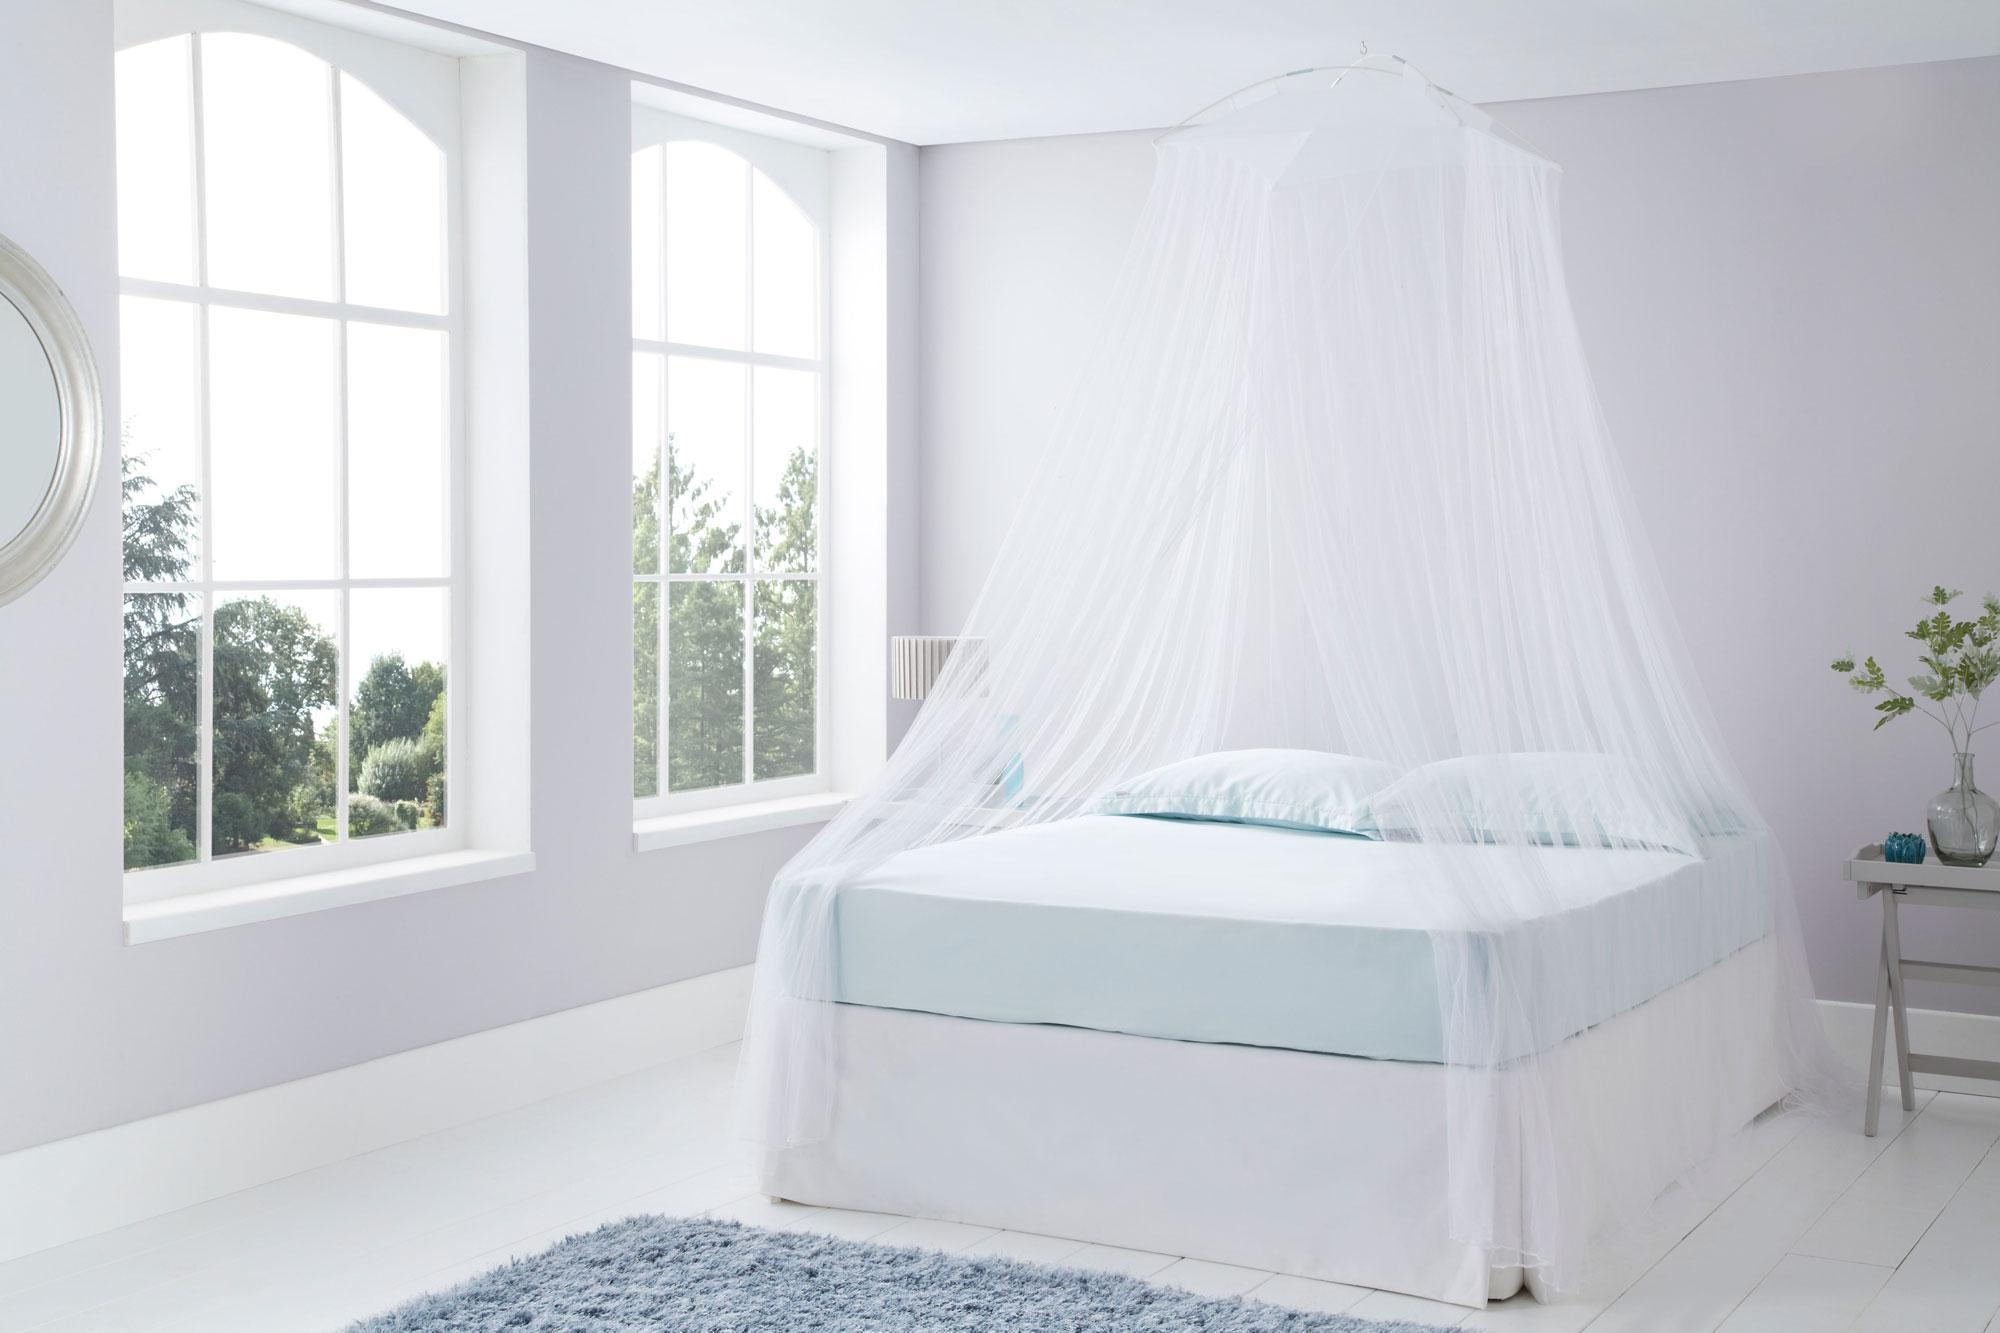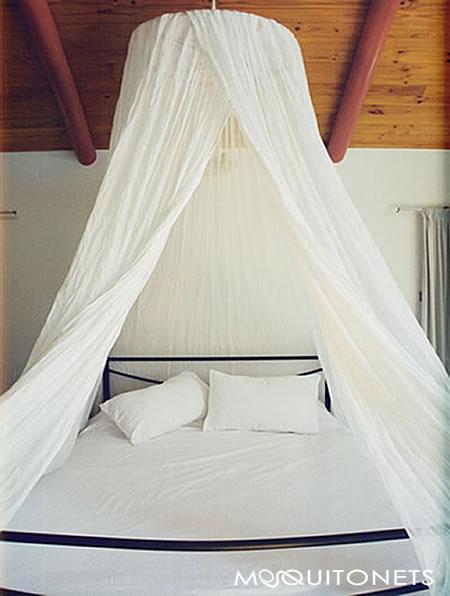The first image is the image on the left, the second image is the image on the right. Examine the images to the left and right. Is the description "In the left image, you can see the entire window; the window top, bottom and both sides are clearly visible." accurate? Answer yes or no. Yes. The first image is the image on the left, the second image is the image on the right. For the images shown, is this caption "There are two circle canopies." true? Answer yes or no. Yes. 